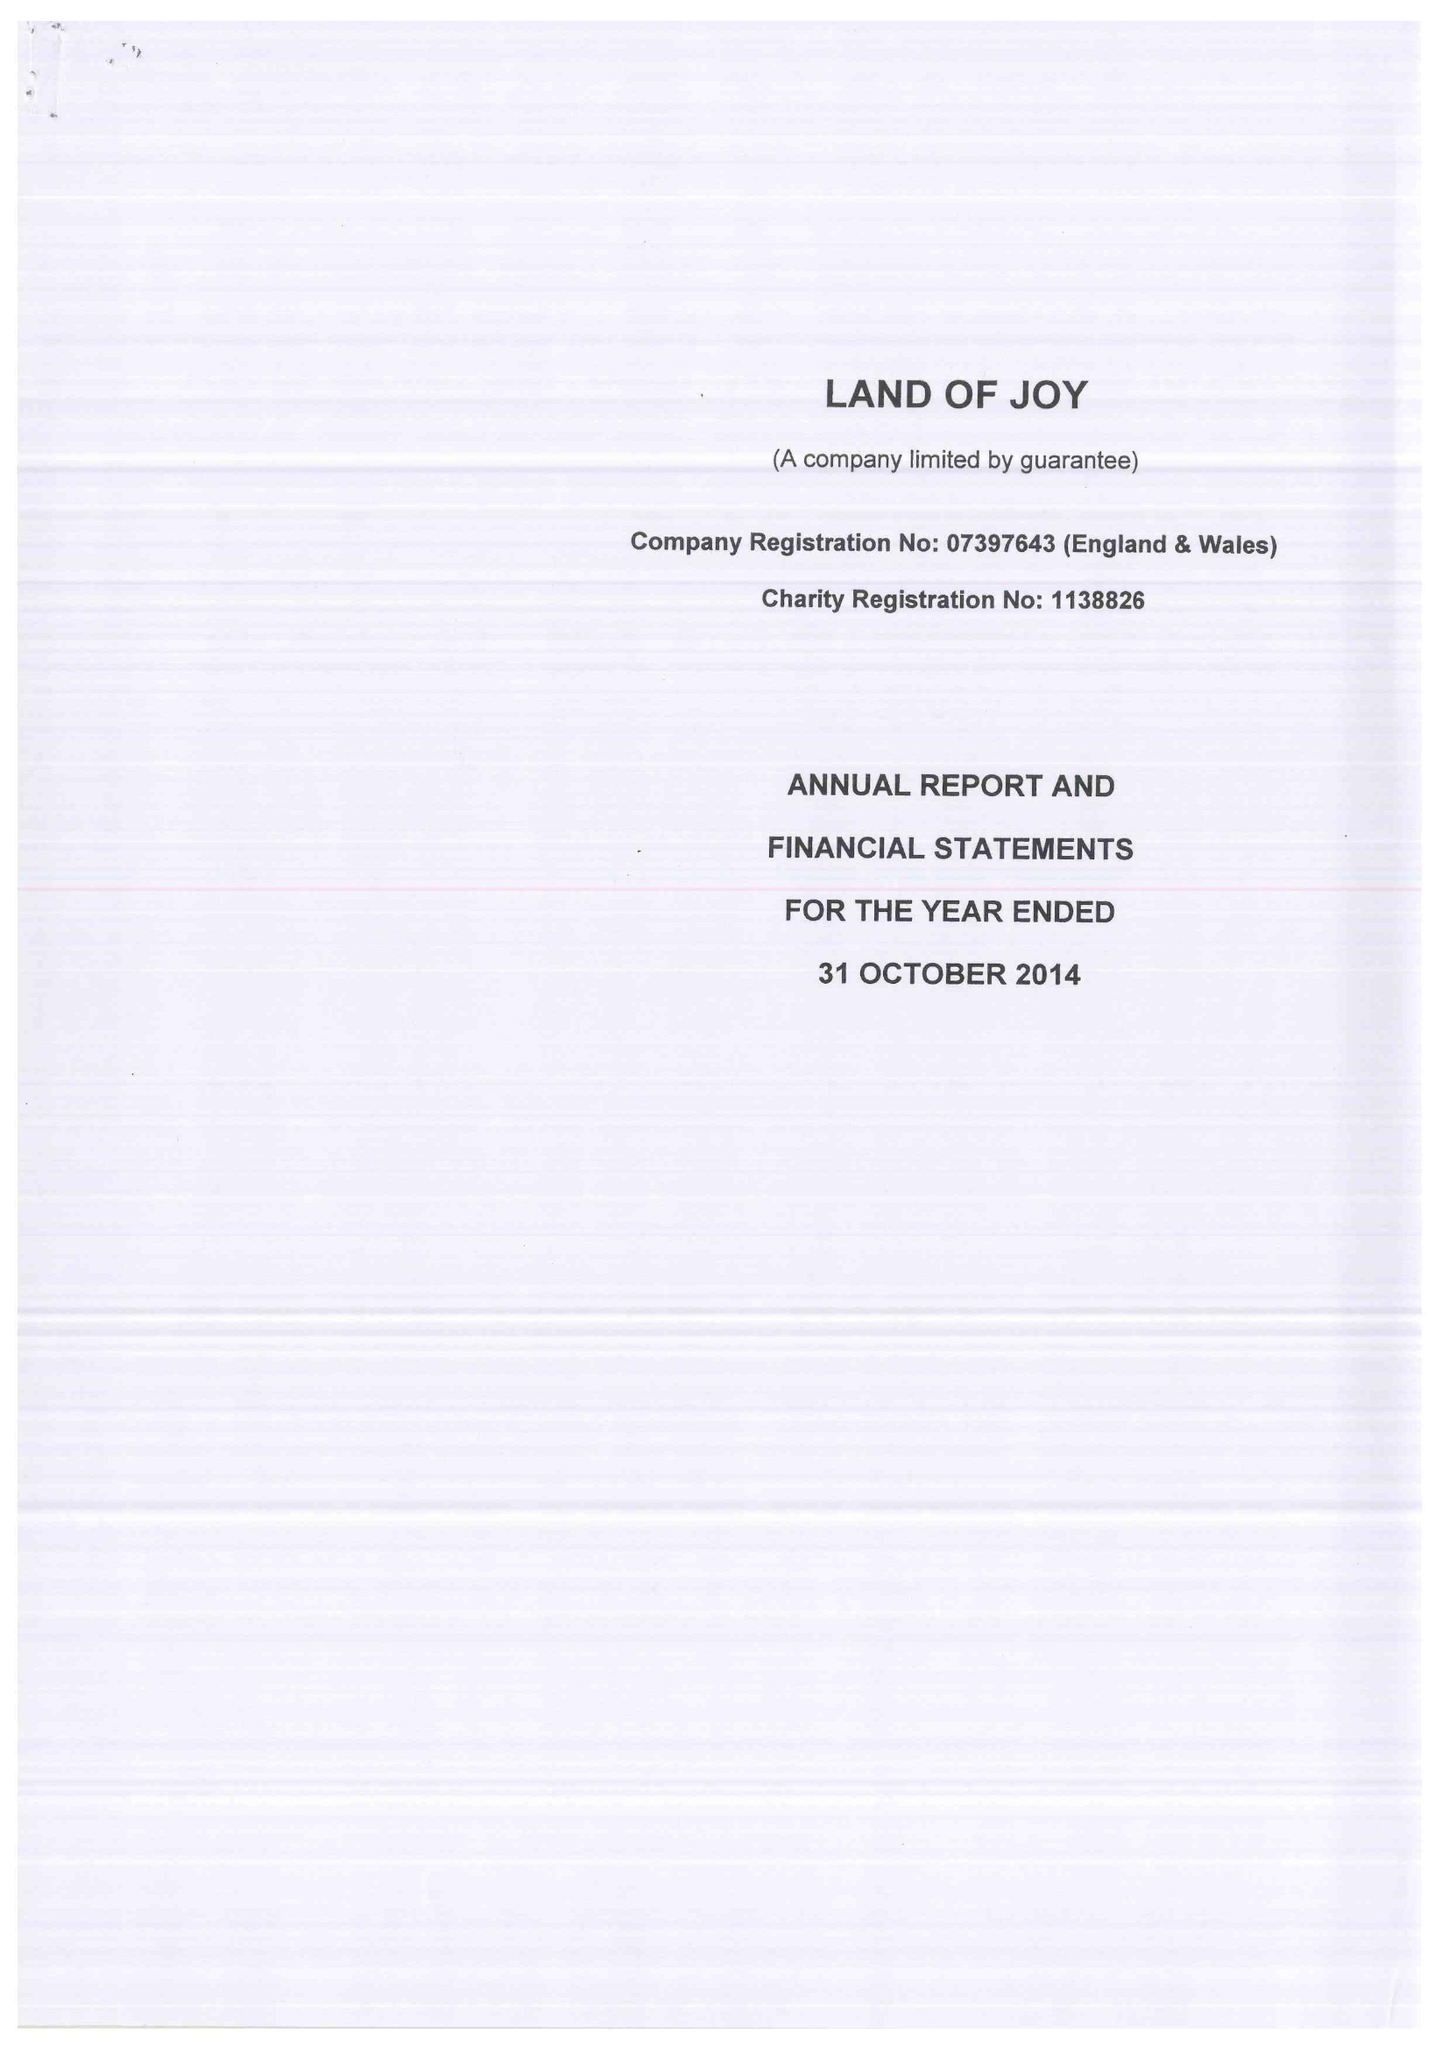What is the value for the address__post_town?
Answer the question using a single word or phrase. HEXHAM 